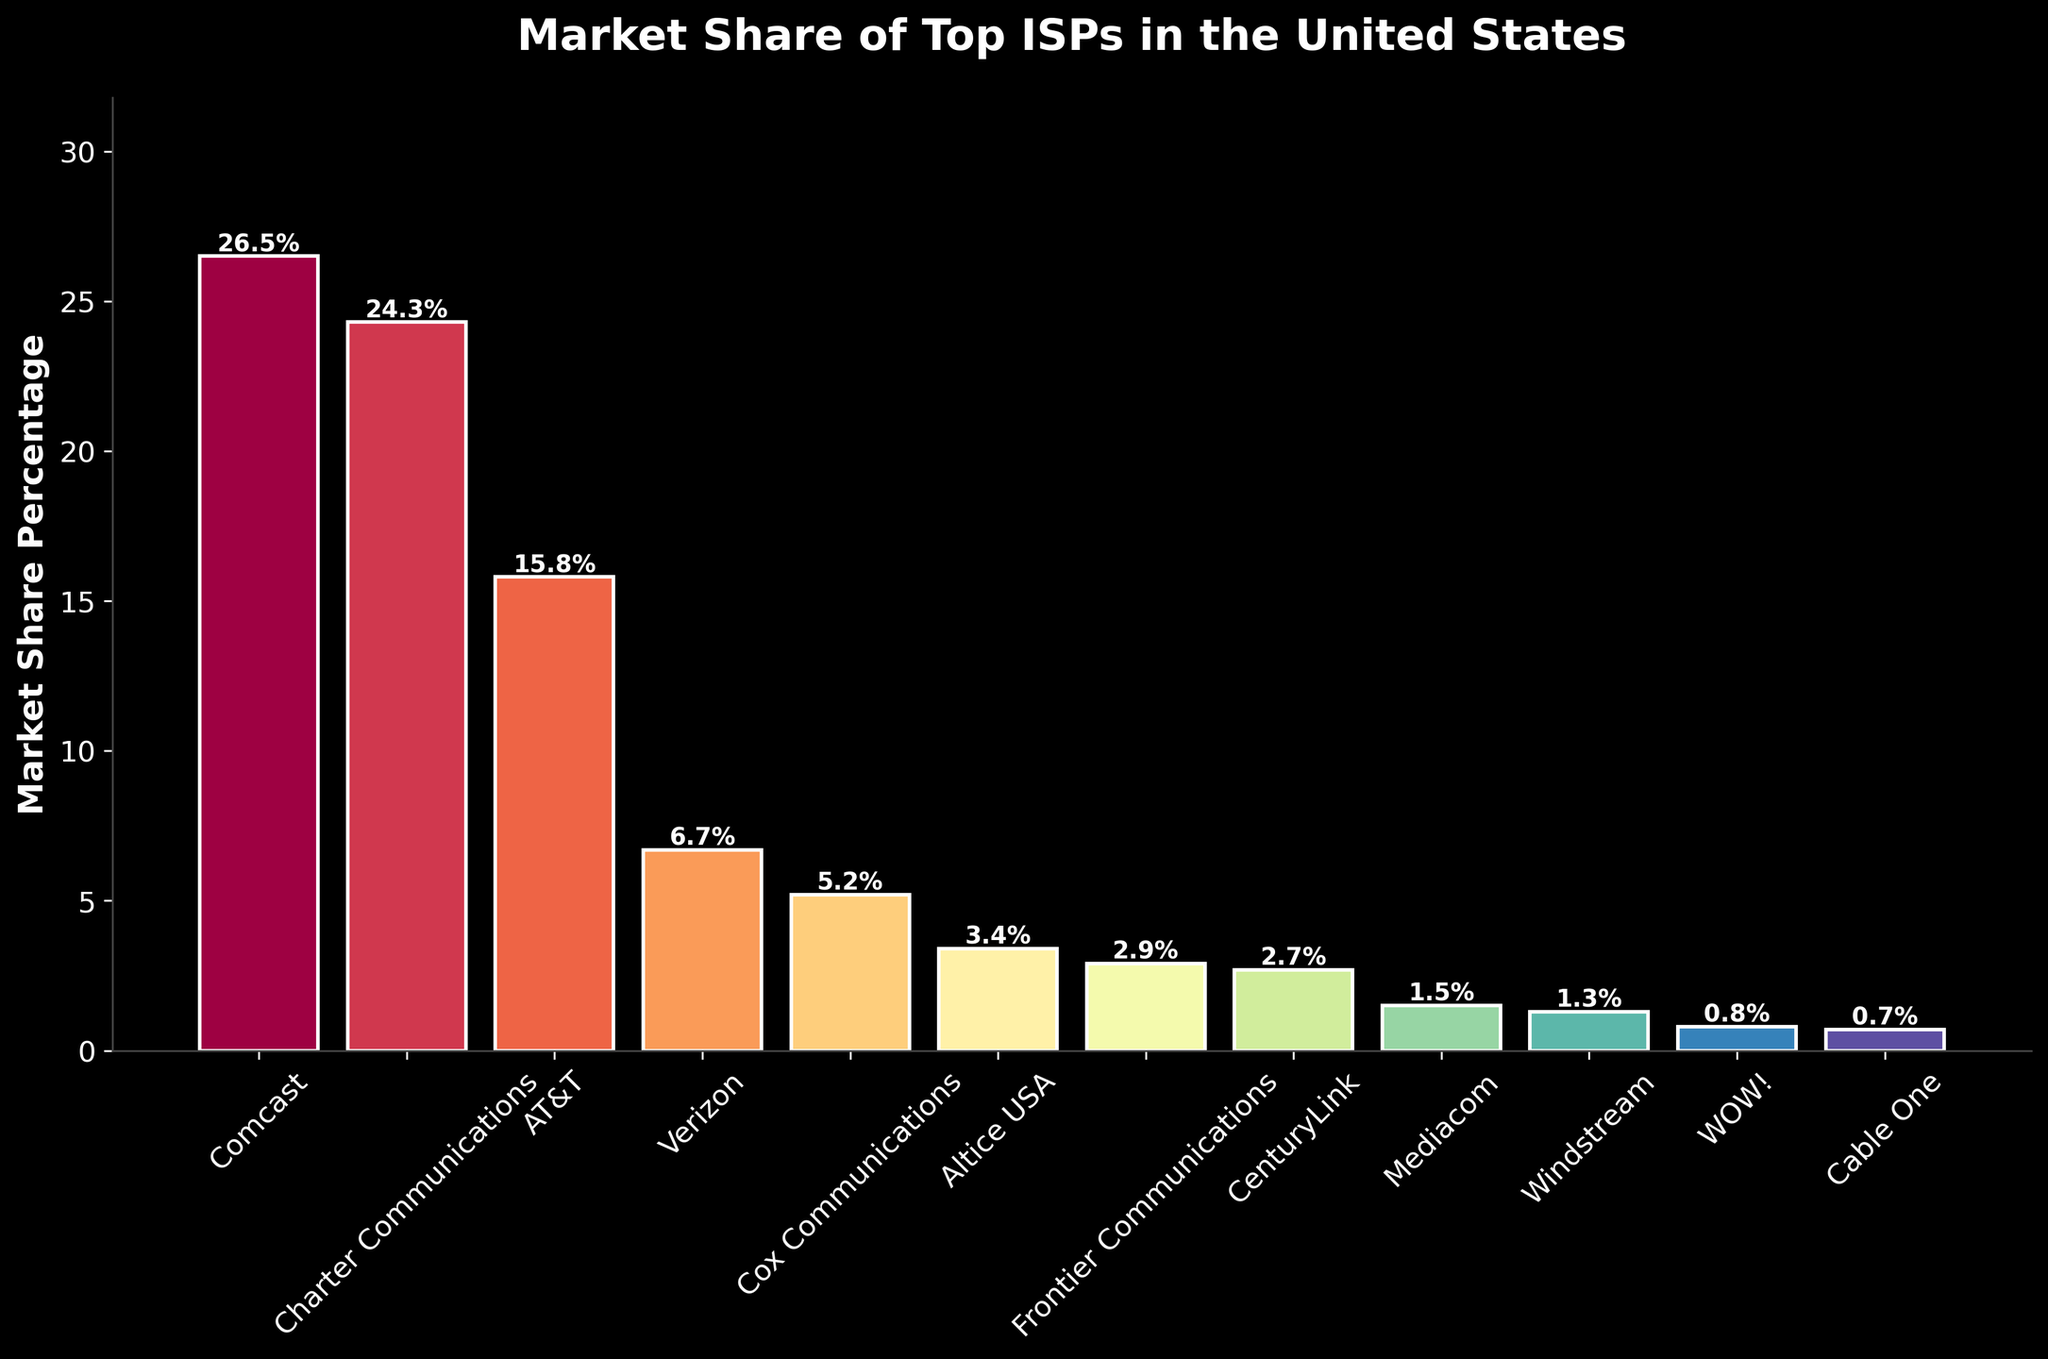Which ISP has the highest market share? By observing the heights of the bars, the bar for Comcast is the tallest, indicating the highest market share.
Answer: Comcast What is the market share difference between Comcast and Charter Communications? The height of the bar for Comcast shows 26.5%, and for Charter Communications, it shows 24.3%. The difference is calculated as 26.5% - 24.3%.
Answer: 2.2% Which ISPs have a market share percentage less than 5%? By inspecting the bars that do not reach the 5% mark on the y-axis, those ISPs are Verizon, Cox Communications, Altice USA, Frontier Communications, CenturyLink, Mediacom, Windstream, WOW!, and Cable One.
Answer: Verizon, Cox Communications, Altice USA, Frontier Communications, CenturyLink, Mediacom, Windstream, WOW!, Cable One If we combine the market shares of AT&T and Verizon, what would be their total market share? AT&T has a market share of 15.8%, and Verizon has 6.7%. Adding these two values gives 15.8% + 6.7%.
Answer: 22.5% Which ISP has the smallest market share, and what is that share? The smallest bar among all the ISPs belongs to Cable One, indicating the smallest market share. The top of this bar shows 0.7%.
Answer: Cable One, 0.7% Is the market share of AT&T more than double that of Cox Communications? AT&T's market share is 15.8%, and Cox Communications' market share is 5.2%. Doubling Cox Communications' share gives 5.2% * 2 = 10.4%, which is less than AT&T's 15.8%. Therefore, AT&T’s market share is more than double that of Cox Communications.
Answer: Yes How many ISPs have a market share between 1% and 3%? Inspecting the bars that lie between the 1% and 3% marks on the y-axis include Frontier Communications (2.9%), CenturyLink (2.7%), Mediacom (1.5%), Windstream (1.3%), and WOW! (0.8%) is excluded as it is below 1%. So, the count is four ISPs.
Answer: Four What fraction of the total market share is captured by the top three ISPs? The market shares for Comcast, Charter Communications, and AT&T are 26.5%, 24.3%, and 15.8%, respectively. Adding these gives 26.5% + 24.3% + 15.8% = 66.6%. The total market share for all listed ISPs is 100%, so the fraction is 66.6% / 100% = 0.666.
Answer: 0.666 Which ISP has a market share closest to the average of the top five ISPs? First, calculate the average market share of the top five ISPs: (26.5 + 24.3 + 15.8 + 6.7 + 5.2) / 5 = 15.7%. The ISP with a market share closest to 15.7% is AT&T with 15.8%.
Answer: AT&T 